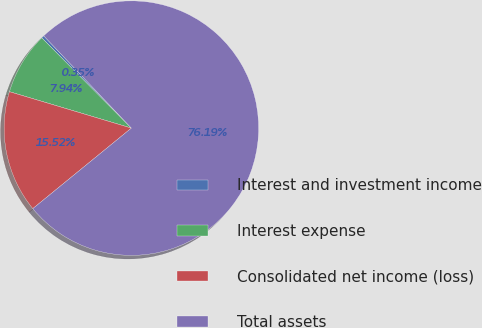<chart> <loc_0><loc_0><loc_500><loc_500><pie_chart><fcel>Interest and investment income<fcel>Interest expense<fcel>Consolidated net income (loss)<fcel>Total assets<nl><fcel>0.35%<fcel>7.94%<fcel>15.52%<fcel>76.19%<nl></chart> 